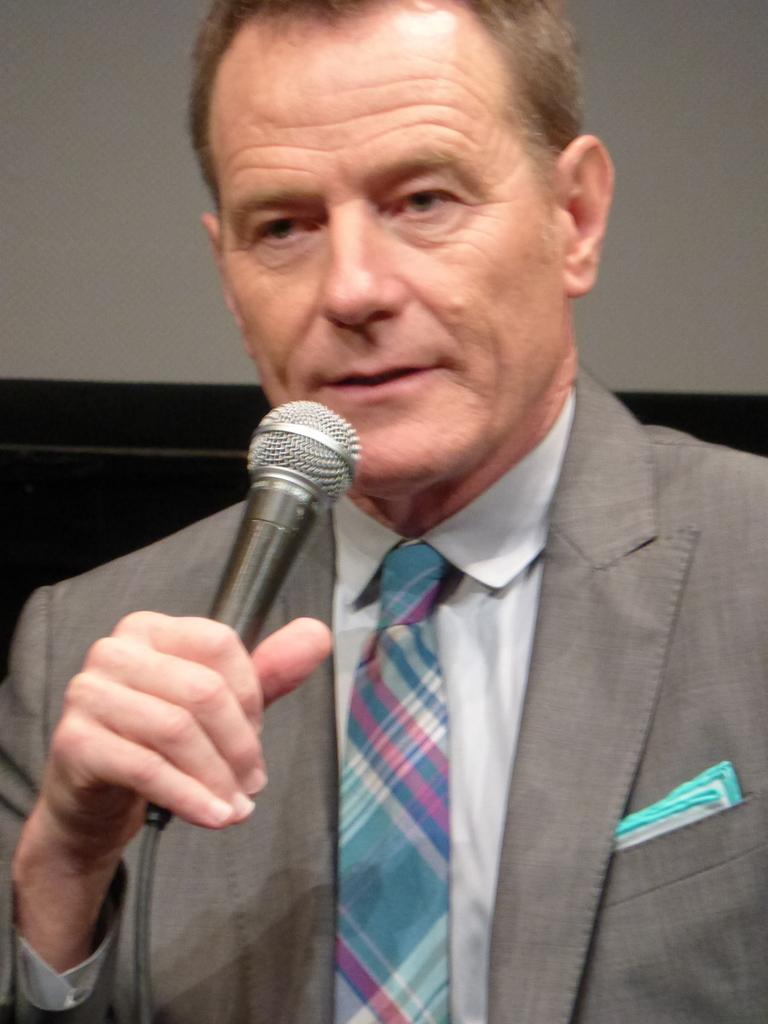What is the main subject of the image? There is a person standing in the middle of the image. What can be seen in the background of the image? There is a wall in the background of the image. What type of punishment is being administered to the person's brothers in the image? There is no mention of any brothers or punishment in the image; it only features a person standing in front of a wall. 